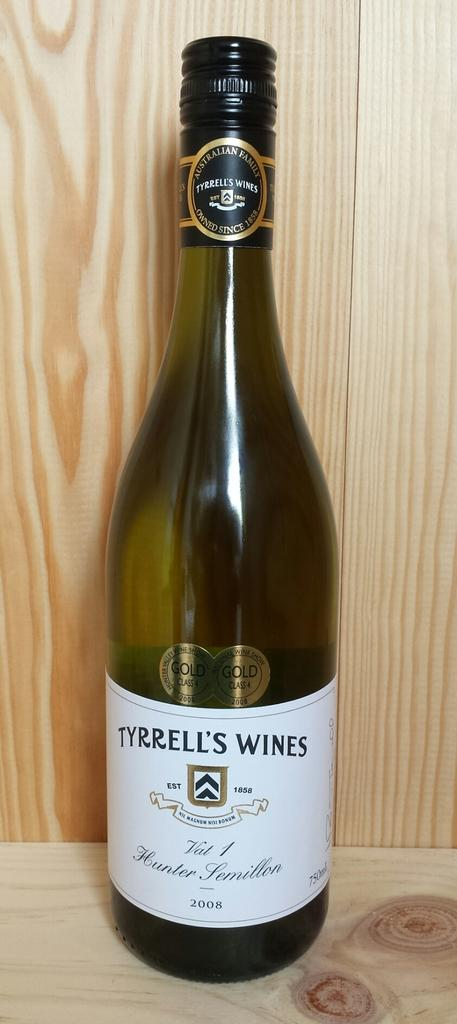<image>
Relay a brief, clear account of the picture shown. A bottle of Tyrrell's Wines vintage 2008 in a wooden cabinet. 